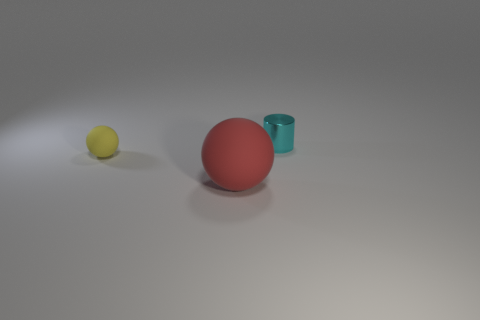What is the large red ball made of?
Your response must be concise. Rubber. Do the tiny thing that is on the left side of the metal cylinder and the small cyan shiny thing have the same shape?
Offer a very short reply. No. What number of objects are either metallic cylinders or big red rubber things?
Your answer should be very brief. 2. Is the small object on the left side of the tiny cyan metallic thing made of the same material as the small cylinder?
Provide a short and direct response. No. How big is the cyan metallic thing?
Make the answer very short. Small. What number of cylinders are tiny rubber objects or big red rubber objects?
Offer a very short reply. 0. Are there the same number of tiny rubber balls that are in front of the large object and cyan objects that are on the left side of the tiny cyan thing?
Give a very brief answer. Yes. There is another rubber thing that is the same shape as the yellow thing; what is its size?
Offer a terse response. Large. How big is the thing that is behind the red rubber thing and on the right side of the yellow matte object?
Your response must be concise. Small. Are there any yellow rubber spheres behind the cyan shiny thing?
Offer a terse response. No. 